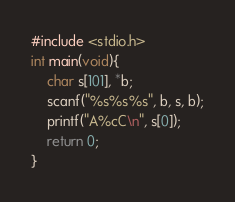<code> <loc_0><loc_0><loc_500><loc_500><_C_>#include <stdio.h>
int main(void){
    char s[101], *b;
    scanf("%s%s%s", b, s, b);
    printf("A%cC\n", s[0]);
    return 0;
}
</code> 